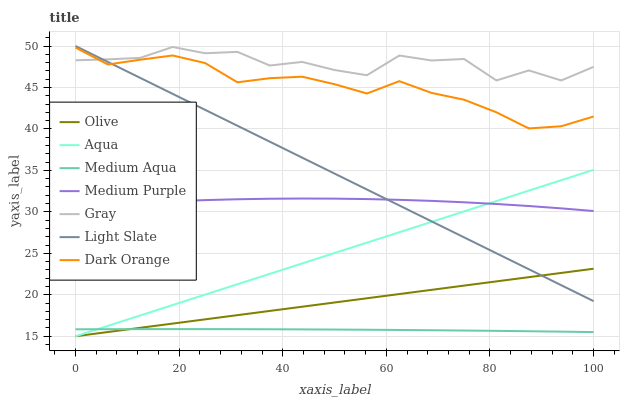Does Medium Aqua have the minimum area under the curve?
Answer yes or no. Yes. Does Gray have the maximum area under the curve?
Answer yes or no. Yes. Does Dark Orange have the minimum area under the curve?
Answer yes or no. No. Does Dark Orange have the maximum area under the curve?
Answer yes or no. No. Is Light Slate the smoothest?
Answer yes or no. Yes. Is Gray the roughest?
Answer yes or no. Yes. Is Dark Orange the smoothest?
Answer yes or no. No. Is Dark Orange the roughest?
Answer yes or no. No. Does Aqua have the lowest value?
Answer yes or no. Yes. Does Dark Orange have the lowest value?
Answer yes or no. No. Does Light Slate have the highest value?
Answer yes or no. Yes. Does Dark Orange have the highest value?
Answer yes or no. No. Is Medium Aqua less than Medium Purple?
Answer yes or no. Yes. Is Dark Orange greater than Medium Aqua?
Answer yes or no. Yes. Does Light Slate intersect Medium Purple?
Answer yes or no. Yes. Is Light Slate less than Medium Purple?
Answer yes or no. No. Is Light Slate greater than Medium Purple?
Answer yes or no. No. Does Medium Aqua intersect Medium Purple?
Answer yes or no. No. 